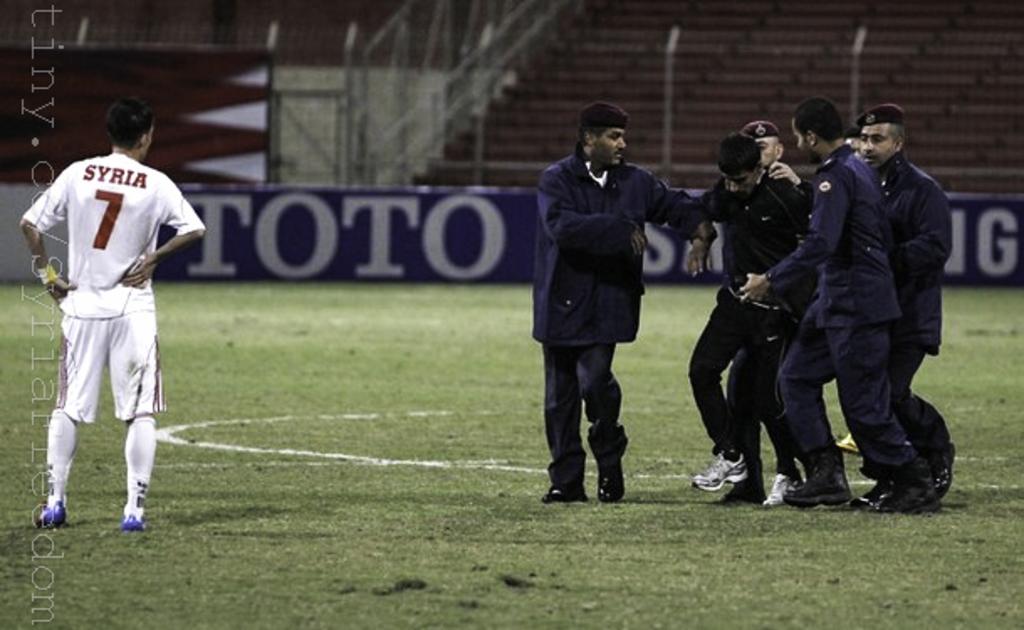What does th sign at the edge of the field say?
Keep it short and to the point. Toto. 